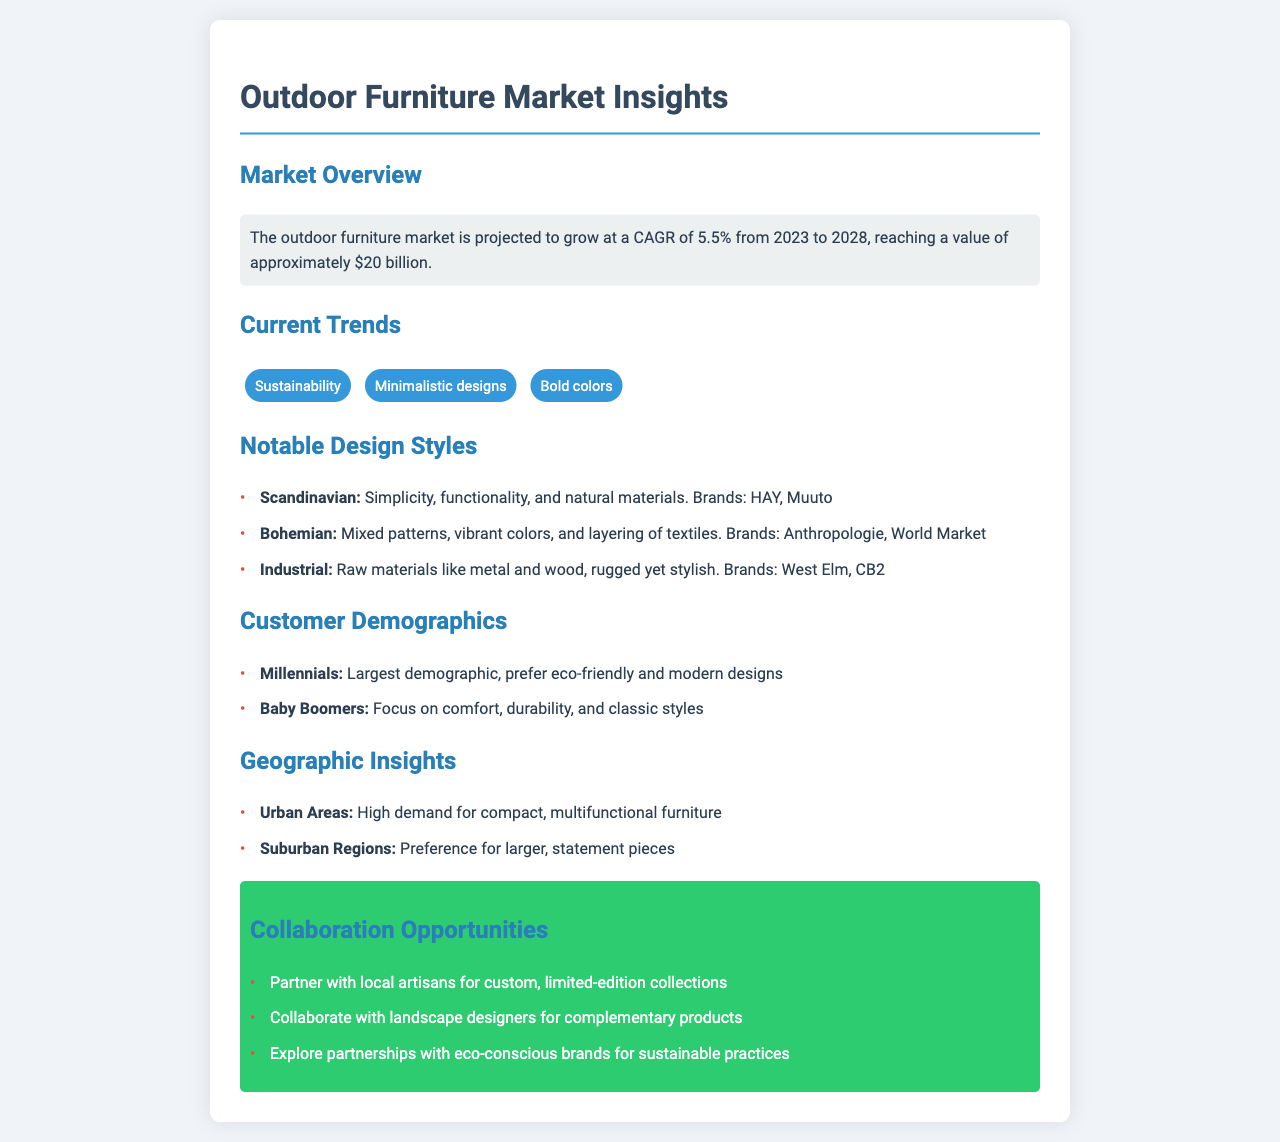What is the projected market growth rate? The document mentions the outdoor furniture market is projected to grow at a CAGR of 5.5% from 2023 to 2028.
Answer: 5.5% What is the estimated market value by 2028? The projected market value by 2028 is approximately $20 billion.
Answer: $20 billion Which design style emphasizes functionality and natural materials? The Scandinavian design style emphasizes simplicity, functionality, and natural materials.
Answer: Scandinavian What do Millennials prefer in outdoor furniture? Millennials prefer eco-friendly and modern designs according to the customer demographics.
Answer: Eco-friendly and modern designs What colors are trending in outdoor furniture? Bold colors are highlighted as a current trend in outdoor furniture.
Answer: Bold colors What type of furniture is in high demand in urban areas? The document states there is high demand for compact, multifunctional furniture in urban areas.
Answer: Compact, multifunctional furniture Which brands are associated with Bohemian design? The brands associated with Bohemian design are Anthropologie and World Market.
Answer: Anthropologie, World Market What opportunities for collaboration are mentioned? The opportunities for collaboration include partnering with local artisans and landscape designers.
Answer: Partnering with local artisans and landscape designers What customer demographic focuses on comfort and durability? The Baby Boomers demographic focuses on comfort, durability, and classic styles.
Answer: Baby Boomers 